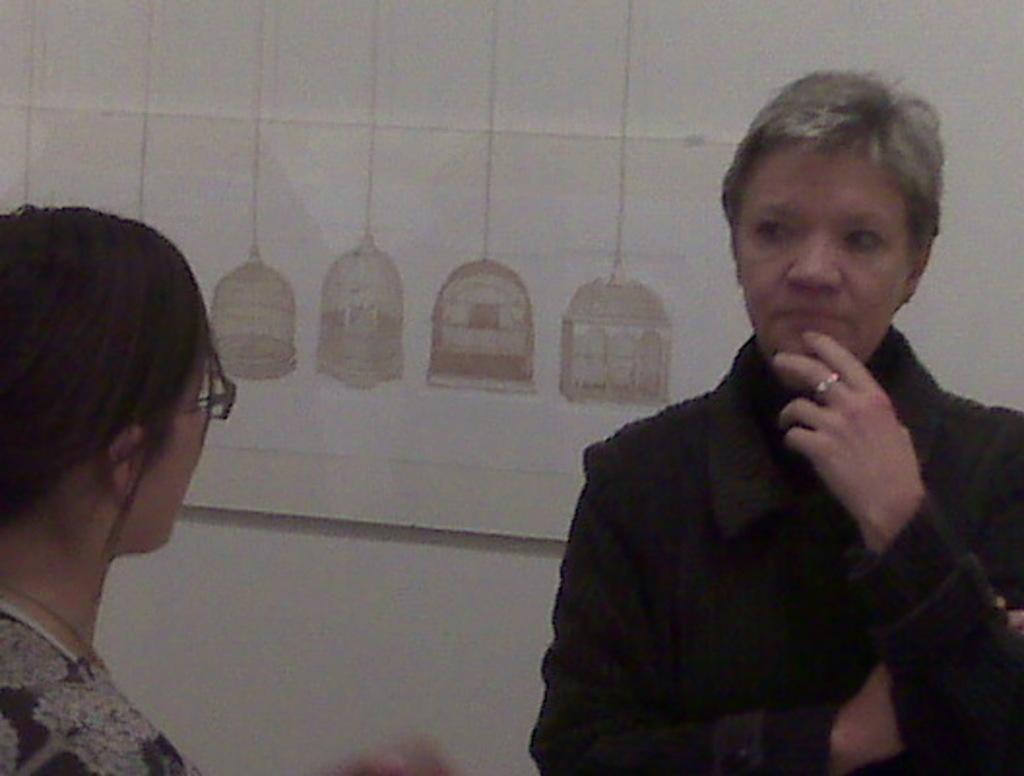Can you describe this image briefly? In this image I can see two women facing each other. I can see a painting on a wall at the top of the image. 